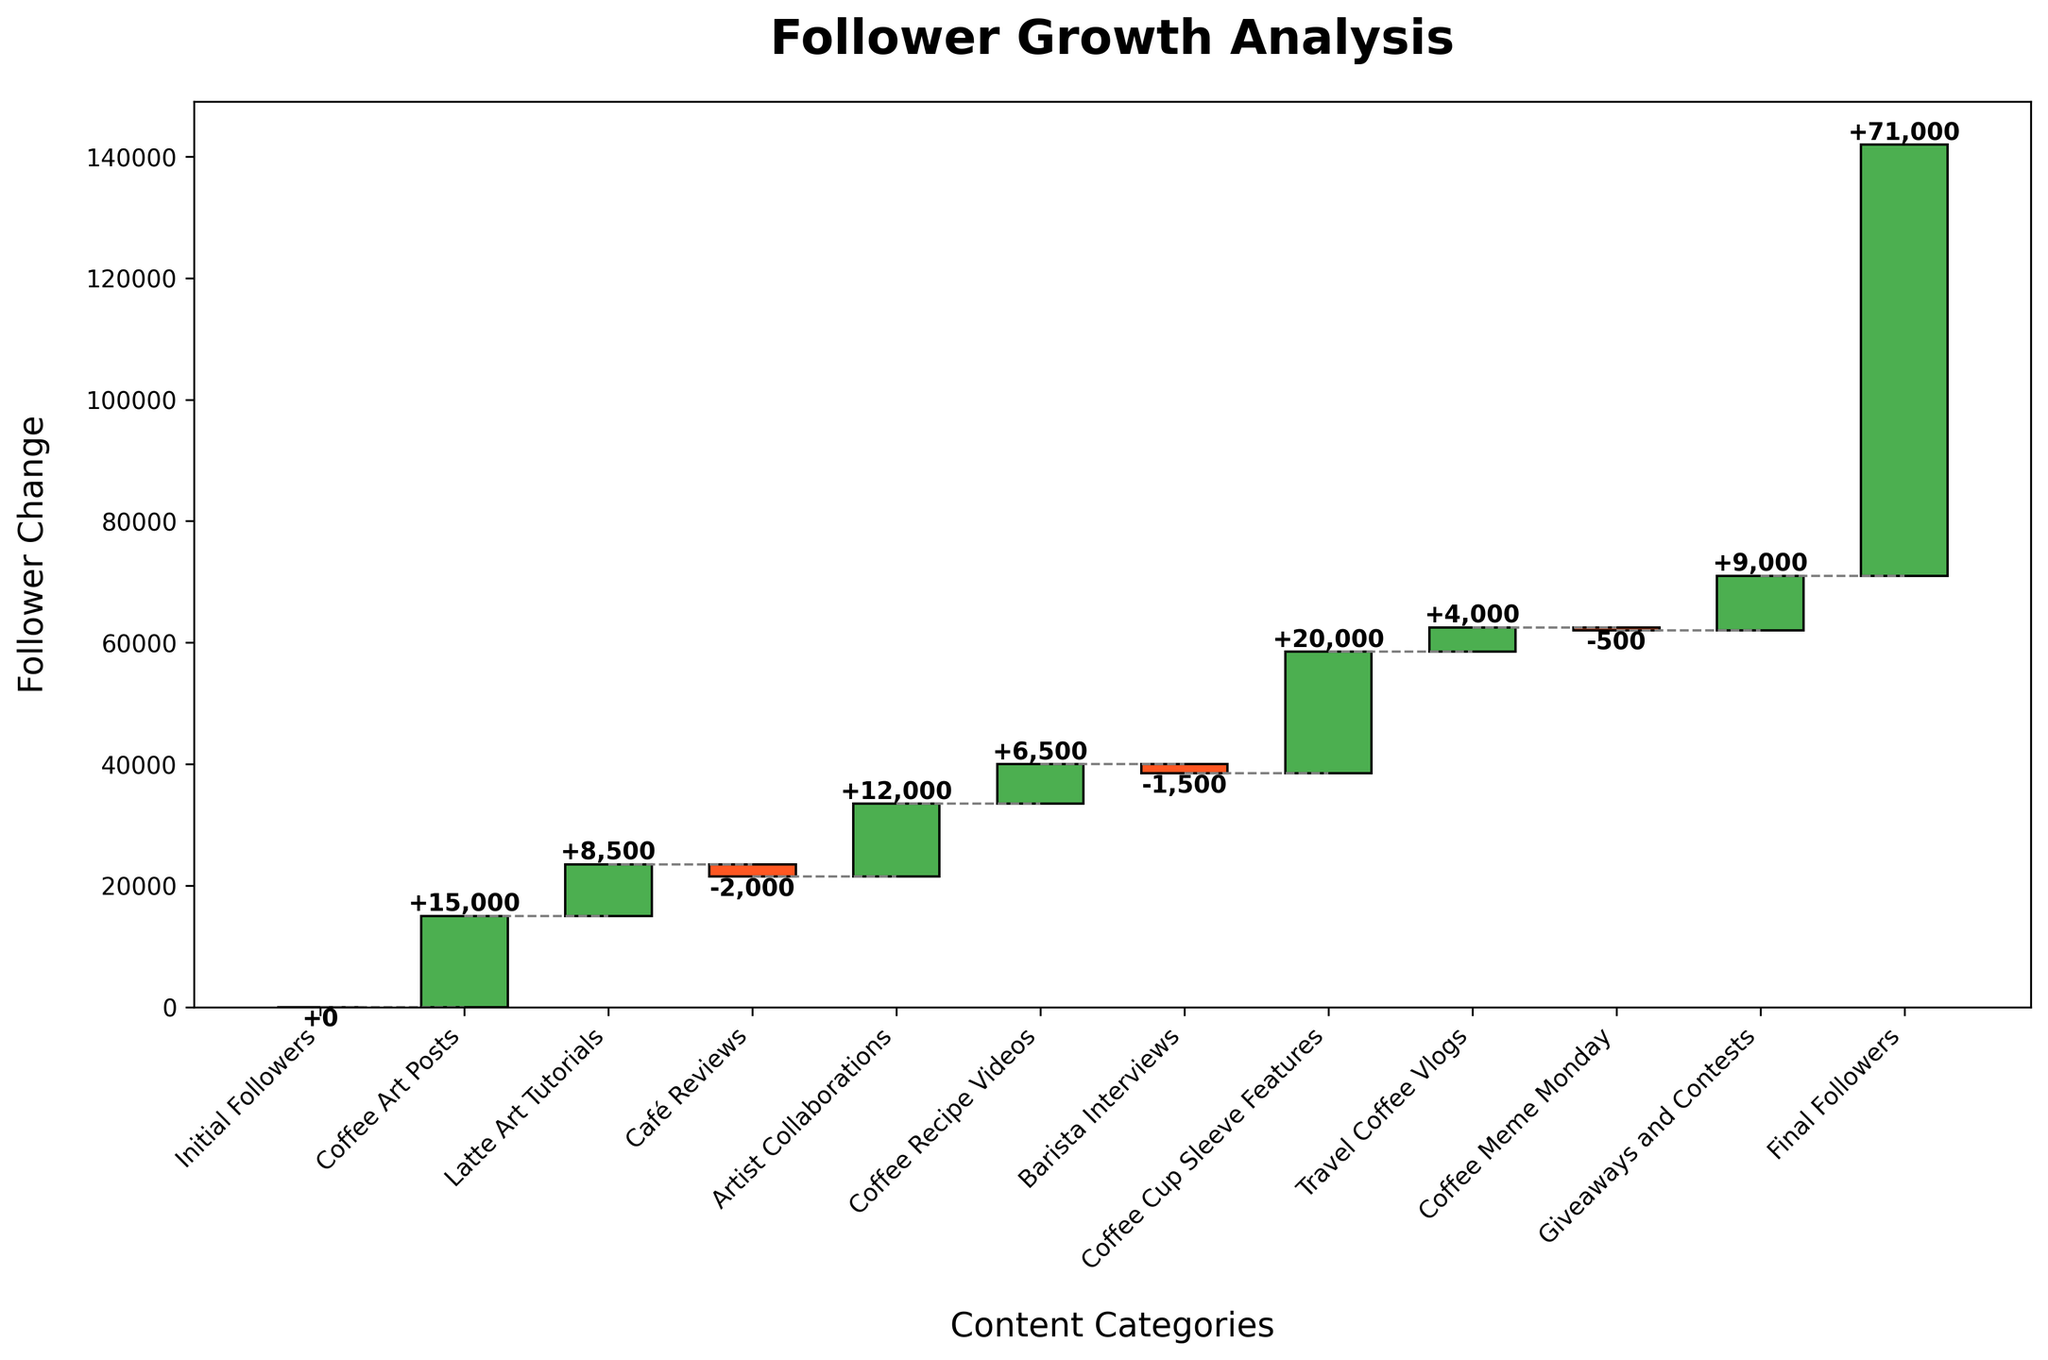What is the title of the plot? The title of the plot is located at the top of the chart and provides a brief description of what the plot is about. In this case, it’s labeled "Follower Growth Analysis".
Answer: Follower Growth Analysis How many categories contributed to follower gains? To find this, count the number of bars that are green (signifying positive change). In this plot, these bars belong to the categories Coffee Art Posts, Latte Art Tutorials, Artist Collaborations, Coffee Recipe Videos, Coffee Cup Sleeve Features, Travel Coffee Vlogs, and Giveaways and Contests.
Answer: 7 Which category resulted in the largest increase in followers? This can be determined by identifying the tallest green bar in the chart. The bar for Coffee Cup Sleeve Features stands out as the tallest one, indicating it brought the most followers.
Answer: Coffee Cup Sleeve Features Which category had a negative impact on follower count? Bars that are red indicate a loss in followers. By looking at the red bars, we can see that Café Reviews, Barista Interviews, and Coffee Meme Monday had negative impacts.
Answer: Café Reviews, Barista Interviews, Coffee Meme Monday What was the total follower change due to Artist Collaborations? This is straightforward as we just look at the height of the bar labeled Artist Collaborations, which shows +12000.
Answer: +12000 What was the net follower gain at the end of the period? The net follower gain can be found at the end of the cumulative line, indicated by the Final Followers bar which marks the accumulated total of 71000 followers.
Answer: 71000 What is the combined follower change from Latte Art Tutorials and Coffee Meme Monday? To find this, add the follower change for Latte Art Tutorials (+8500) and subtract the change for Coffee Meme Monday (-500). So it is 8500 - 500.
Answer: +8000 How does the follower gain from Coffee Cup Sleeve Features compare to the gain from Coffee Art Posts? Compare the height of the green bars for both categories. Coffee Cup Sleeve Features has a follower gain of +20000 while Coffee Art Posts has +15000. Since 20000 is greater than 15000, Coffee Cup Sleeve Features led to a greater follower gain.
Answer: Coffee Cup Sleeve Features > Coffee Art Posts What is the drop in followers after factoring in Café Reviews and Barista Interviews? Add the negative impacts of both categories: -2000 from Café Reviews and -1500 from Barista Interviews. So, the total drop is -2000 - 1500.
Answer: -3500 Considering both gains and losses, did more categories lead to a positive or negative follower change? Count the number of green and red bars to compare. With 7 categories leading to follower gains and 3 categories leading to losses, more categories resulted in positive changes.
Answer: Positive 